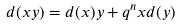Convert formula to latex. <formula><loc_0><loc_0><loc_500><loc_500>d ( x y ) = d ( x ) y + q ^ { n } x d ( y )</formula> 